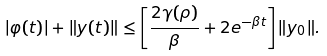Convert formula to latex. <formula><loc_0><loc_0><loc_500><loc_500>| \varphi ( t ) | + \| y ( t ) \| \leq \left [ \frac { 2 \gamma ( \rho ) } { \beta } + 2 { e ^ { - \beta t } } \right ] \| y _ { 0 } \| .</formula> 